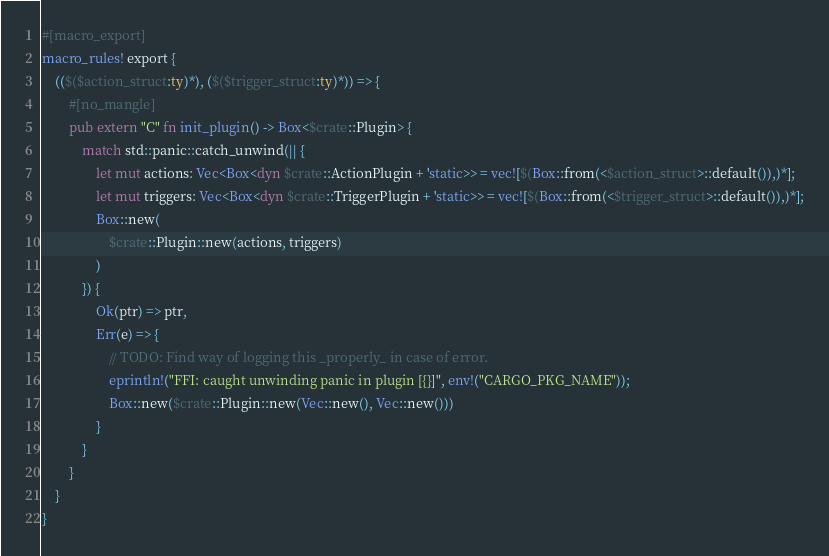<code> <loc_0><loc_0><loc_500><loc_500><_Rust_>#[macro_export]
macro_rules! export {
    (($($action_struct:ty)*), ($($trigger_struct:ty)*)) => {
        #[no_mangle]
        pub extern "C" fn init_plugin() -> Box<$crate::Plugin> {
            match std::panic::catch_unwind(|| {
                let mut actions: Vec<Box<dyn $crate::ActionPlugin + 'static>> = vec![$(Box::from(<$action_struct>::default()),)*];
                let mut triggers: Vec<Box<dyn $crate::TriggerPlugin + 'static>> = vec![$(Box::from(<$trigger_struct>::default()),)*];
                Box::new(
                    $crate::Plugin::new(actions, triggers)
                )
            }) {
                Ok(ptr) => ptr,
                Err(e) => {
                    // TODO: Find way of logging this _properly_ in case of error.
                    eprintln!("FFI: caught unwinding panic in plugin [{}]", env!("CARGO_PKG_NAME"));
                    Box::new($crate::Plugin::new(Vec::new(), Vec::new()))
                }
            }
        }
    }
}
</code> 